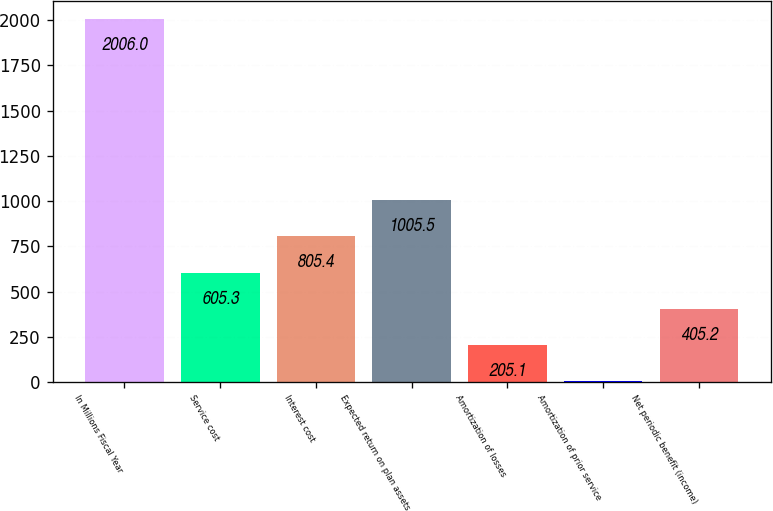<chart> <loc_0><loc_0><loc_500><loc_500><bar_chart><fcel>In Millions Fiscal Year<fcel>Service cost<fcel>Interest cost<fcel>Expected return on plan assets<fcel>Amortization of losses<fcel>Amortization of prior service<fcel>Net periodic benefit (income)<nl><fcel>2006<fcel>605.3<fcel>805.4<fcel>1005.5<fcel>205.1<fcel>5<fcel>405.2<nl></chart> 